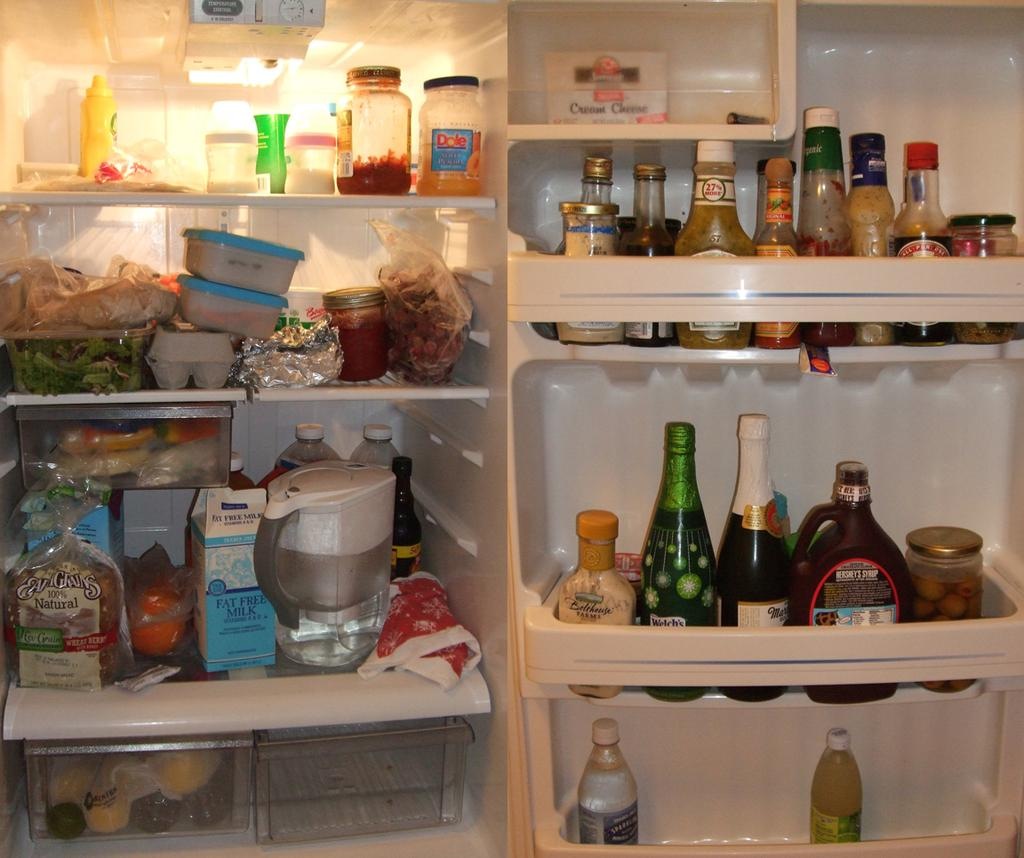<image>
Offer a succinct explanation of the picture presented. An open refrigerator that is full of many things including a carton of fat free milk. 